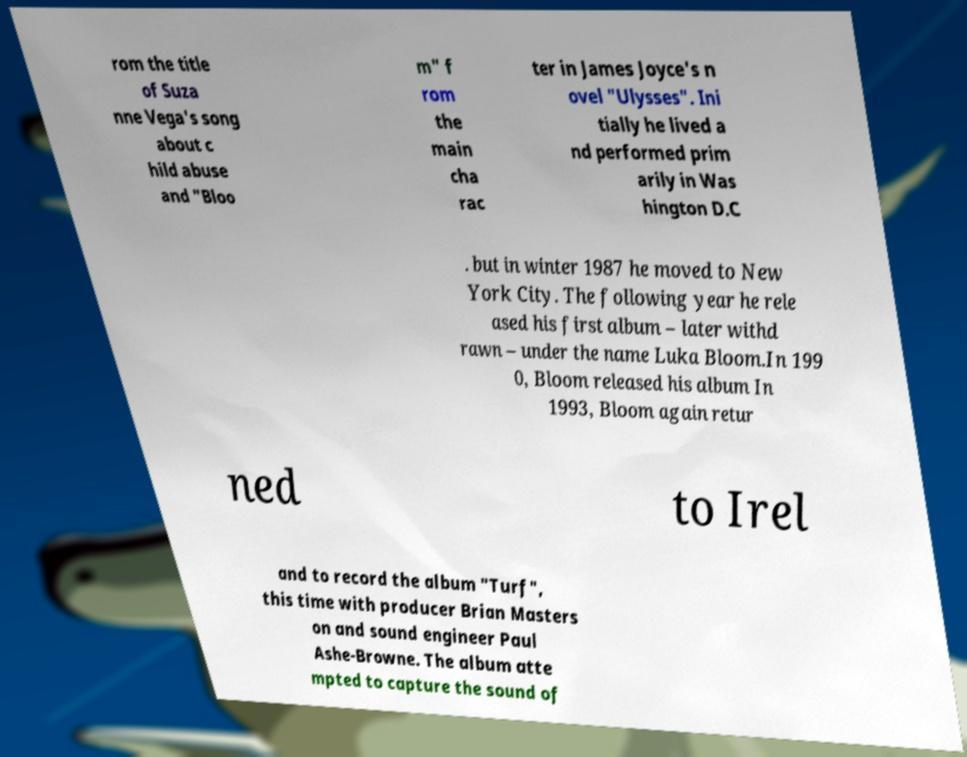Can you read and provide the text displayed in the image?This photo seems to have some interesting text. Can you extract and type it out for me? rom the title of Suza nne Vega's song about c hild abuse and "Bloo m" f rom the main cha rac ter in James Joyce's n ovel "Ulysses". Ini tially he lived a nd performed prim arily in Was hington D.C . but in winter 1987 he moved to New York City. The following year he rele ased his first album – later withd rawn – under the name Luka Bloom.In 199 0, Bloom released his album In 1993, Bloom again retur ned to Irel and to record the album "Turf", this time with producer Brian Masters on and sound engineer Paul Ashe-Browne. The album atte mpted to capture the sound of 